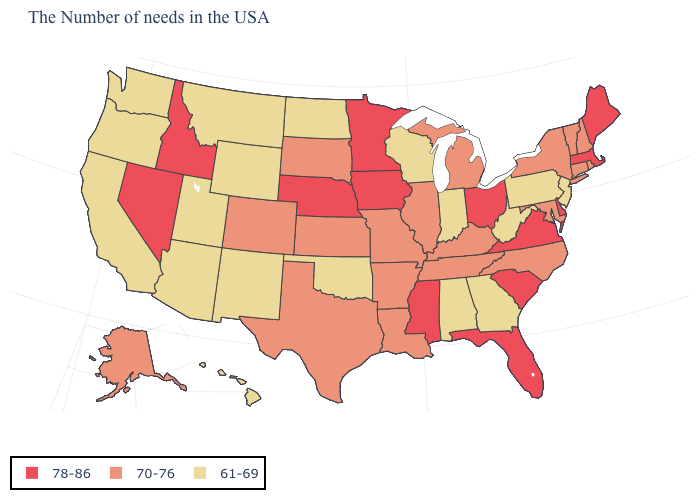Name the states that have a value in the range 70-76?
Quick response, please. Rhode Island, New Hampshire, Vermont, Connecticut, New York, Maryland, North Carolina, Michigan, Kentucky, Tennessee, Illinois, Louisiana, Missouri, Arkansas, Kansas, Texas, South Dakota, Colorado, Alaska. What is the value of California?
Concise answer only. 61-69. Is the legend a continuous bar?
Write a very short answer. No. What is the value of Nebraska?
Quick response, please. 78-86. Name the states that have a value in the range 78-86?
Answer briefly. Maine, Massachusetts, Delaware, Virginia, South Carolina, Ohio, Florida, Mississippi, Minnesota, Iowa, Nebraska, Idaho, Nevada. Does the map have missing data?
Short answer required. No. Does New York have the lowest value in the Northeast?
Short answer required. No. Name the states that have a value in the range 61-69?
Be succinct. New Jersey, Pennsylvania, West Virginia, Georgia, Indiana, Alabama, Wisconsin, Oklahoma, North Dakota, Wyoming, New Mexico, Utah, Montana, Arizona, California, Washington, Oregon, Hawaii. What is the highest value in the USA?
Quick response, please. 78-86. Does the first symbol in the legend represent the smallest category?
Short answer required. No. Does New Mexico have the highest value in the USA?
Short answer required. No. Name the states that have a value in the range 61-69?
Answer briefly. New Jersey, Pennsylvania, West Virginia, Georgia, Indiana, Alabama, Wisconsin, Oklahoma, North Dakota, Wyoming, New Mexico, Utah, Montana, Arizona, California, Washington, Oregon, Hawaii. Name the states that have a value in the range 78-86?
Write a very short answer. Maine, Massachusetts, Delaware, Virginia, South Carolina, Ohio, Florida, Mississippi, Minnesota, Iowa, Nebraska, Idaho, Nevada. Which states hav the highest value in the West?
Concise answer only. Idaho, Nevada. What is the highest value in the USA?
Be succinct. 78-86. 